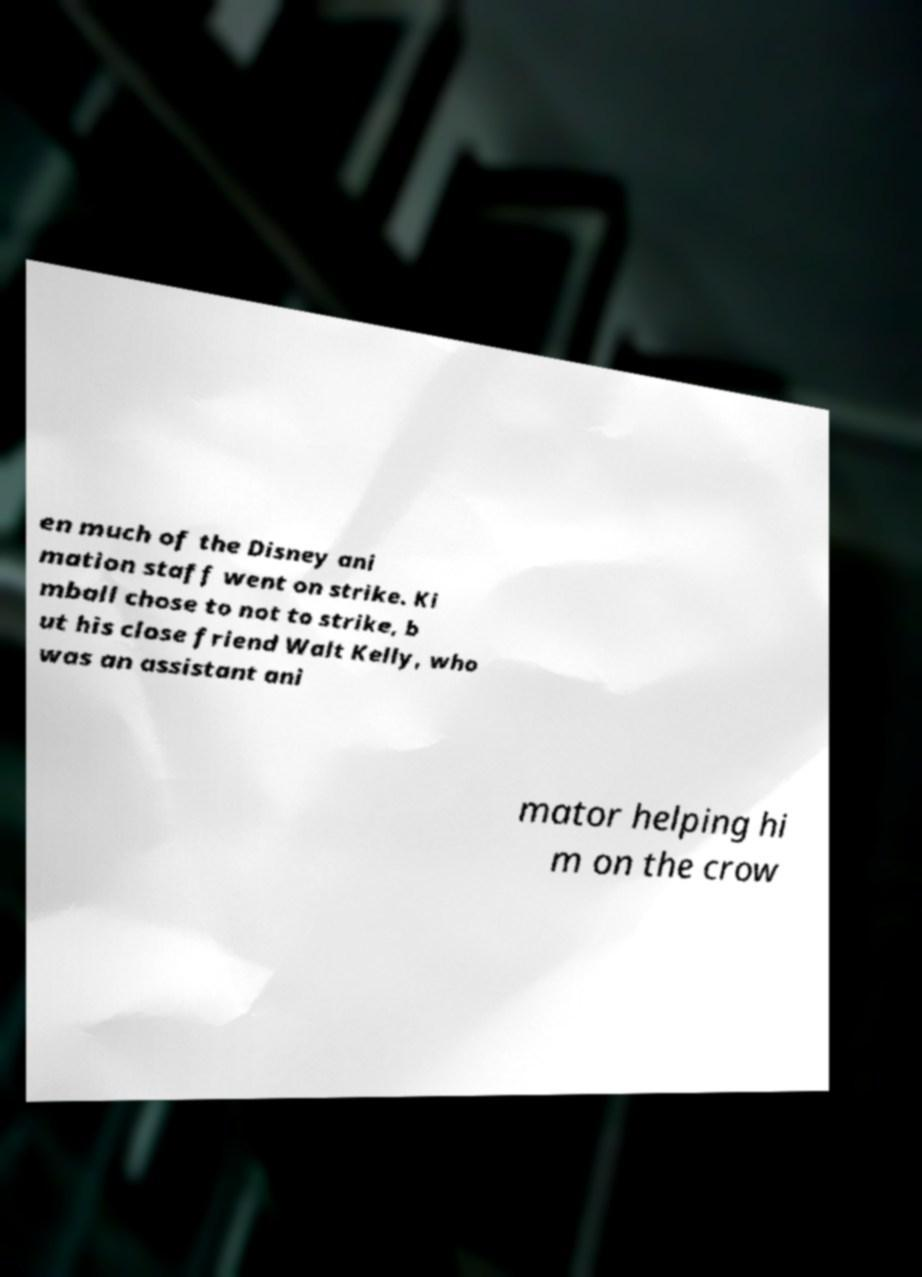Please read and relay the text visible in this image. What does it say? en much of the Disney ani mation staff went on strike. Ki mball chose to not to strike, b ut his close friend Walt Kelly, who was an assistant ani mator helping hi m on the crow 